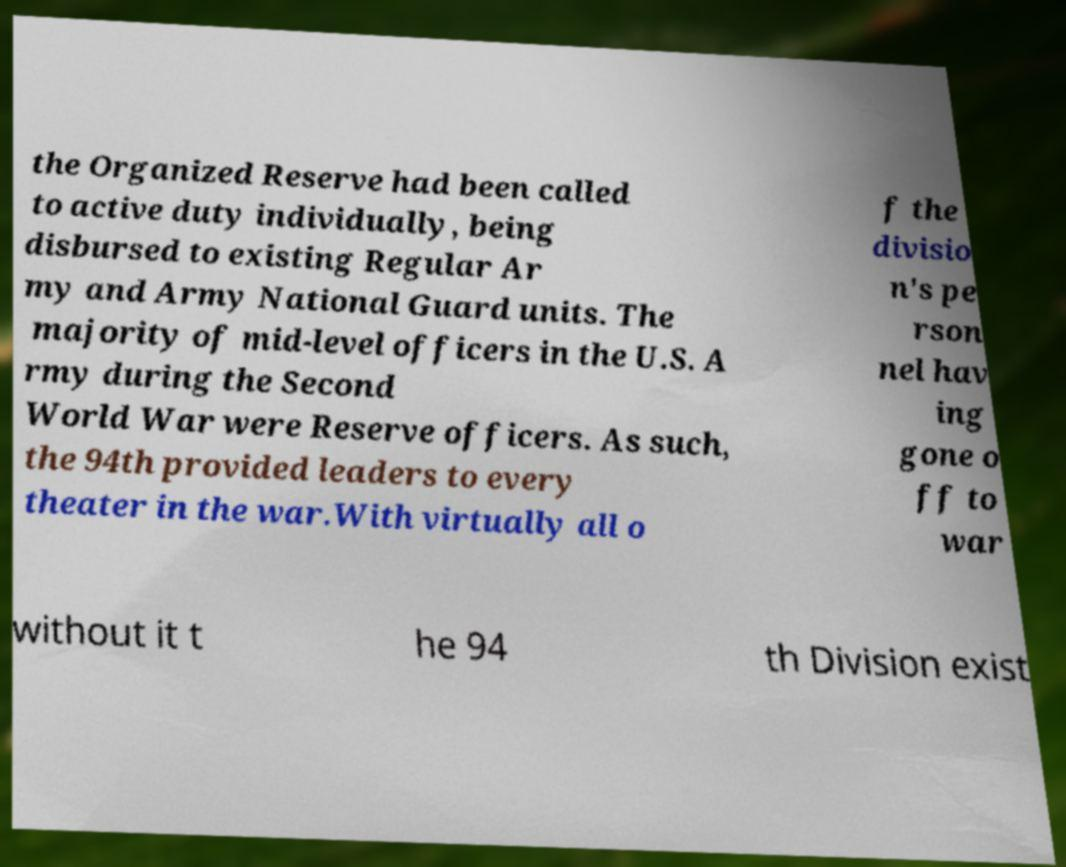There's text embedded in this image that I need extracted. Can you transcribe it verbatim? the Organized Reserve had been called to active duty individually, being disbursed to existing Regular Ar my and Army National Guard units. The majority of mid-level officers in the U.S. A rmy during the Second World War were Reserve officers. As such, the 94th provided leaders to every theater in the war.With virtually all o f the divisio n's pe rson nel hav ing gone o ff to war without it t he 94 th Division exist 